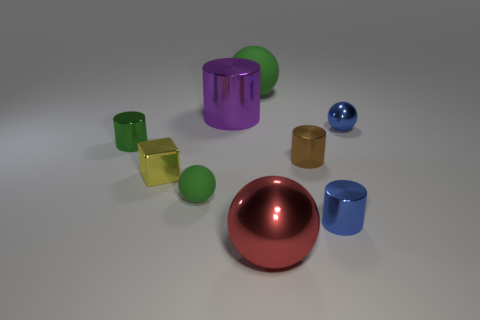What number of balls have the same color as the tiny metallic cube?
Provide a succinct answer. 0. There is a yellow cube that is the same material as the small green cylinder; what size is it?
Make the answer very short. Small. How many things are either large green matte things or tiny cyan cylinders?
Ensure brevity in your answer.  1. The object that is in front of the small blue cylinder is what color?
Your answer should be very brief. Red. The brown metal object that is the same shape as the large purple object is what size?
Keep it short and to the point. Small. How many things are metallic cylinders on the right side of the purple thing or objects that are on the right side of the tiny matte sphere?
Offer a terse response. 6. What is the size of the metallic cylinder that is both in front of the blue ball and left of the brown cylinder?
Offer a very short reply. Small. Does the large purple metal object have the same shape as the green thing that is to the left of the tiny matte sphere?
Offer a terse response. Yes. What number of things are either green objects to the right of the large purple metal cylinder or big shiny cylinders?
Give a very brief answer. 2. Is the small green ball made of the same material as the small blue cylinder in front of the yellow object?
Ensure brevity in your answer.  No. 